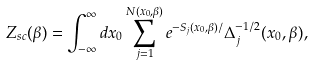Convert formula to latex. <formula><loc_0><loc_0><loc_500><loc_500>Z _ { s c } ( \beta ) = \int _ { - \infty } ^ { \infty } d x _ { 0 } \sum _ { j = 1 } ^ { N ( x _ { 0 } , \beta ) } e ^ { - S _ { j } ( x _ { 0 } , \beta ) / } \Delta _ { j } ^ { - 1 / 2 } ( x _ { 0 } , \beta ) ,</formula> 